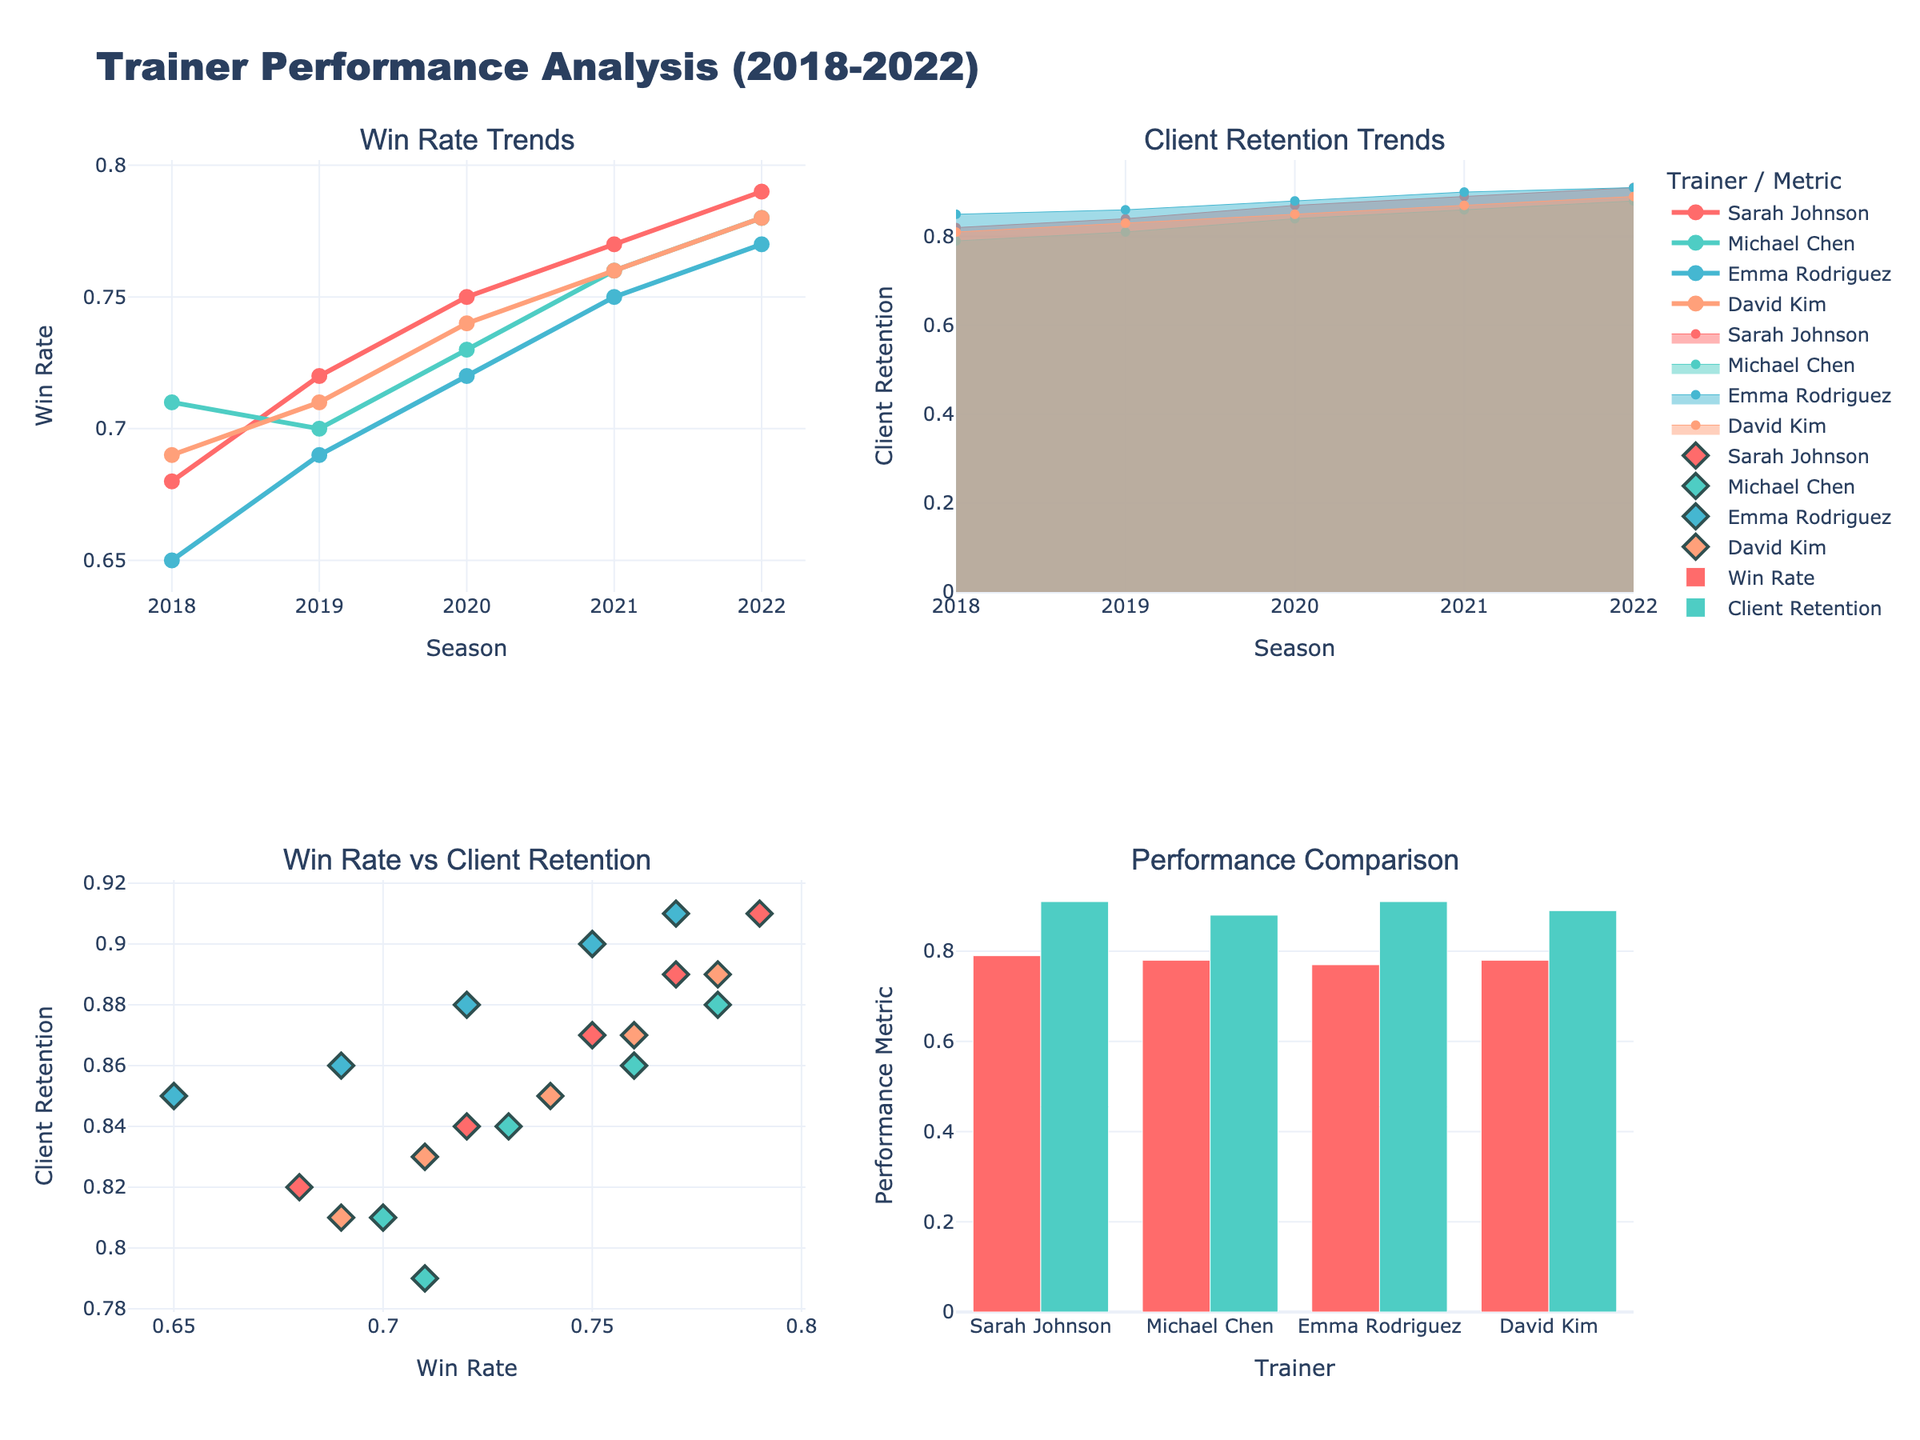What is the title of the figure? The title is prominently displayed at the top of the figure and reads "Trainer Performance Analysis (2018-2022)".
Answer: Trainer Performance Analysis (2018-2022) How many trainers are compared in the figure across the subplots? There are four trainers being compared in the figure as indicated by the legend and labels: Sarah Johnson, Michael Chen, Emma Rodriguez, and David Kim.
Answer: Four Which trainer had the highest client retention in 2020? In the "Client Retention Trends" subplot, the 2020 marker for Emma Rodriguez reaches the highest point among all trainers.
Answer: Emma Rodriguez In the "Performance Comparison" bar plot, who has the highest win rate in 2022? The bars indicate win rates for 2022 in the "Performance Comparison" subplot; Sarah Johnson and Michael Chen have overlapping high bars, both reaching the maximum win rates among others.
Answer: Both Which subplot shows the relationship between two performance metrics? The "Win Rate vs Client Retention" subplot displays the relationship between Win Rate and Client Retention for each trainer using scatter points.
Answer: Win Rate vs Client Retention What is the trend in Sarah Johnson's win rate from 2018 to 2022? In the "Win Rate Trends" subplot, Sarah Johnson's line graph shows an increasing trend from 0.68 in 2018 to 0.79 in 2022.
Answer: Increasing Compare Sarah Johnson's and David Kim's client retention rates in 2021, who is higher? In the "Client Retention Trends" subplot, in 2021, Sarah Johnson's client retention rate is 0.89, while David Kim's is 0.87.
Answer: Sarah Johnson What is the combined client retention for Sarah Johnson and Michael Chen in 2019? Sum the client retention of Sarah Johnson (0.84) and Michael Chen (0.81) for the year 2019. 0.84 + 0.81 = 1.65
Answer: 1.65 Who has the lowest client retention in 2018? In the "Client Retention Trends" subplot, Michael Chen's area plot is the lowest for the 2018 timestamps.
Answer: Michael Chen 